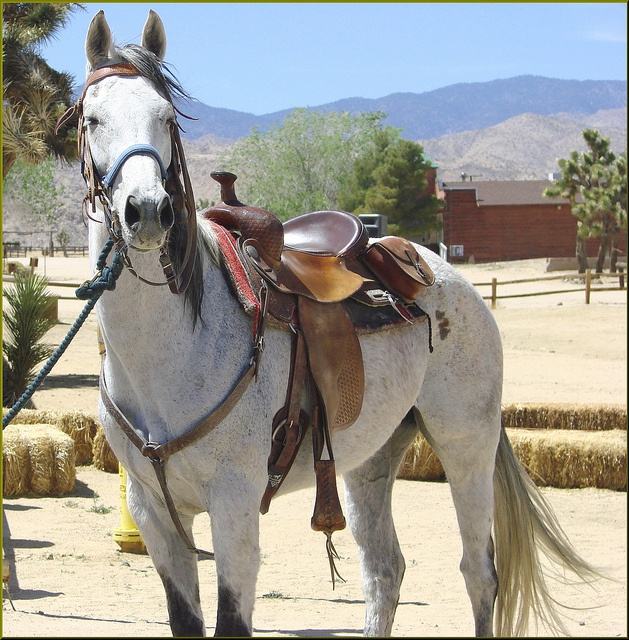Describe the objects in this image and their specific colors. I can see a horse in olive, darkgray, gray, and black tones in this image. 